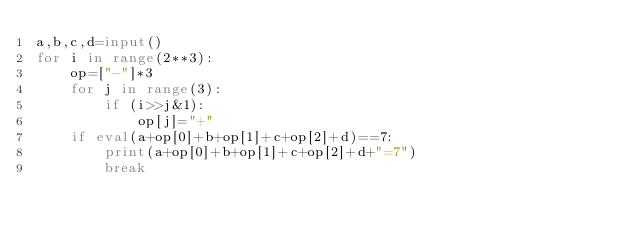<code> <loc_0><loc_0><loc_500><loc_500><_Python_>a,b,c,d=input()
for i in range(2**3):
    op=["-"]*3
    for j in range(3):
        if (i>>j&1):
            op[j]="+"
    if eval(a+op[0]+b+op[1]+c+op[2]+d)==7:
        print(a+op[0]+b+op[1]+c+op[2]+d+"=7")
        break</code> 